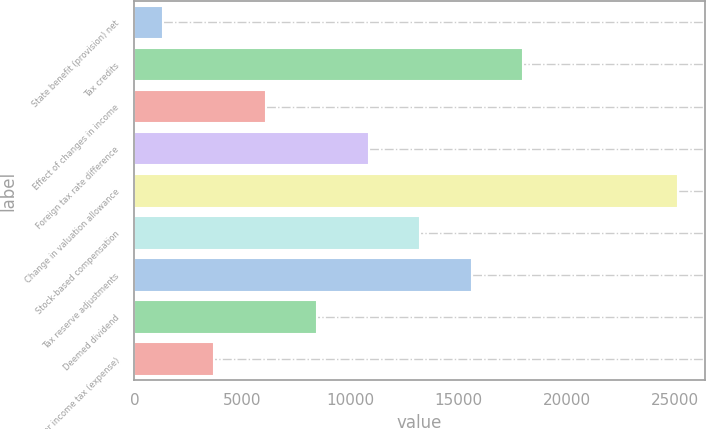Convert chart. <chart><loc_0><loc_0><loc_500><loc_500><bar_chart><fcel>State benefit (provision) net<fcel>Tax credits<fcel>Effect of changes in income<fcel>Foreign tax rate difference<fcel>Change in valuation allowance<fcel>Stock-based compensation<fcel>Tax reserve adjustments<fcel>Deemed dividend<fcel>Other income tax (expense)<nl><fcel>1320<fcel>17980<fcel>6080<fcel>10840<fcel>25120<fcel>13220<fcel>15600<fcel>8460<fcel>3700<nl></chart> 